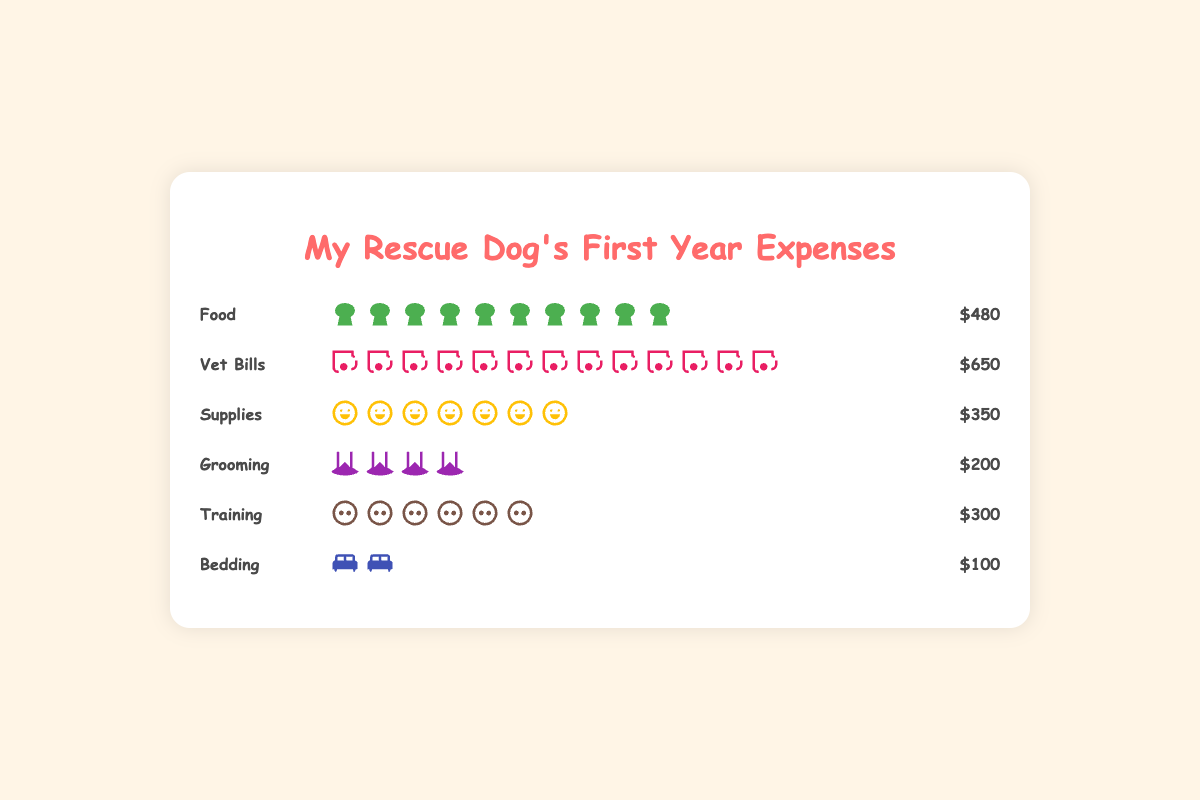What is the title of the figure? The title is displayed at the top of the figure, which helps to identify the main topic being illustrated. In this case, the title reads "My Rescue Dog's First Year Expenses".
Answer: My Rescue Dog's First Year Expenses Which category has the highest expenses? By observing the length of the bars and the corresponding amounts, it is clear that "Vet Bills" has the longest bar with an icon count of 13 and a monetary value of $650, indicating it is the highest.
Answer: Vet Bills How much more did you spend on Vet Bills compared to Grooming? First, determine the amount for each category: Vet Bills is $650 and Grooming is $200. Subtract the smaller amount from the larger one: $650 - $200 = $450.
Answer: $450 What is the total expense for Food and Supplies combined? Sum the amounts for the Food and Supplies categories. Food costs $480 and Supplies cost $350. Adding these together gives $480 + $350 = $830.
Answer: $830 Which category has the least expenses? By comparing the bars and their amounts, Bedding has the shortest bar with only 2 icons and an amount of $100, indicating it has the least expenses.
Answer: Bedding How many categories have expenses greater than $300? Identify the categories and their amounts: Food ($480), Vet Bills ($650), Supplies ($350), Grooming ($200), Training ($300), Bedding ($100). Check which are greater than $300: Food, Vet Bills, and Supplies. There are 3 categories greater than $300.
Answer: 3 If you combine the expenses for Training and Bedding, how does it compare to the expense for Food? Training is $300 and Bedding is $100. Combining them yields $300 + $100 = $400. Since Food is $480, compare the two amounts: $400 < $480.
Answer: Less What percentage of the total expenses does the Food category represent? Calculate the total expenses by summing all categories: $480 (Food) + $650 (Vet Bills) + $350 (Supplies) + $200 (Grooming) + $300 (Training) + $100 (Bedding) = $2080. Then, divide the Food expense by the total and multiply by 100: ($480 / $2080) * 100 ≈ 23.08%.
Answer: 23.08% What is the difference in expenses between Supplies and Training? Supplies cost $350 and Training costs $300. Subtract the smaller amount from the larger one: $350 - $300 = $50.
Answer: $50 Approximately how many icons represent Vet Bills in the figure? Each icon typically represents a certain value. Given the total Vet Bills amount is $650, count the number of stethoscope icons which is 13.
Answer: 13 